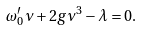Convert formula to latex. <formula><loc_0><loc_0><loc_500><loc_500>\omega _ { 0 } ^ { \prime } \nu + 2 g \nu ^ { 3 } - \lambda = 0 .</formula> 